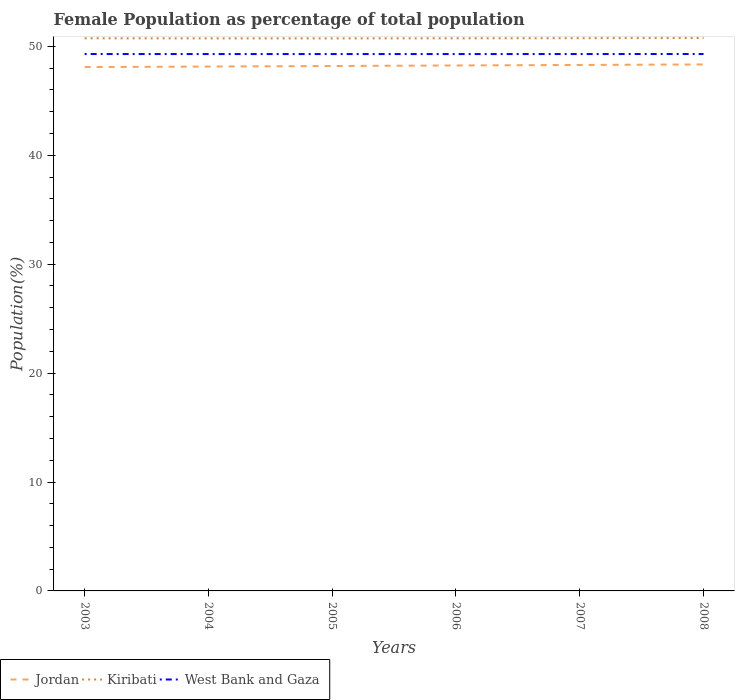How many different coloured lines are there?
Make the answer very short. 3. Does the line corresponding to West Bank and Gaza intersect with the line corresponding to Jordan?
Keep it short and to the point. No. Is the number of lines equal to the number of legend labels?
Keep it short and to the point. Yes. Across all years, what is the maximum female population in in West Bank and Gaza?
Keep it short and to the point. 49.29. In which year was the female population in in Kiribati maximum?
Give a very brief answer. 2005. What is the total female population in in Kiribati in the graph?
Provide a short and direct response. -0.01. What is the difference between the highest and the second highest female population in in Jordan?
Ensure brevity in your answer.  0.24. How many lines are there?
Offer a terse response. 3. Does the graph contain any zero values?
Make the answer very short. No. Does the graph contain grids?
Your answer should be compact. No. Where does the legend appear in the graph?
Your response must be concise. Bottom left. How are the legend labels stacked?
Provide a short and direct response. Horizontal. What is the title of the graph?
Provide a short and direct response. Female Population as percentage of total population. What is the label or title of the X-axis?
Keep it short and to the point. Years. What is the label or title of the Y-axis?
Make the answer very short. Population(%). What is the Population(%) in Jordan in 2003?
Your response must be concise. 48.09. What is the Population(%) of Kiribati in 2003?
Offer a terse response. 50.74. What is the Population(%) of West Bank and Gaza in 2003?
Your answer should be very brief. 49.29. What is the Population(%) of Jordan in 2004?
Provide a short and direct response. 48.14. What is the Population(%) in Kiribati in 2004?
Keep it short and to the point. 50.73. What is the Population(%) in West Bank and Gaza in 2004?
Offer a terse response. 49.29. What is the Population(%) in Jordan in 2005?
Provide a short and direct response. 48.19. What is the Population(%) of Kiribati in 2005?
Your answer should be compact. 50.73. What is the Population(%) of West Bank and Gaza in 2005?
Ensure brevity in your answer.  49.29. What is the Population(%) of Jordan in 2006?
Give a very brief answer. 48.24. What is the Population(%) in Kiribati in 2006?
Make the answer very short. 50.73. What is the Population(%) in West Bank and Gaza in 2006?
Provide a succinct answer. 49.29. What is the Population(%) in Jordan in 2007?
Ensure brevity in your answer.  48.29. What is the Population(%) of Kiribati in 2007?
Your answer should be compact. 50.75. What is the Population(%) of West Bank and Gaza in 2007?
Provide a short and direct response. 49.29. What is the Population(%) of Jordan in 2008?
Give a very brief answer. 48.34. What is the Population(%) in Kiribati in 2008?
Make the answer very short. 50.76. What is the Population(%) of West Bank and Gaza in 2008?
Keep it short and to the point. 49.29. Across all years, what is the maximum Population(%) of Jordan?
Your answer should be very brief. 48.34. Across all years, what is the maximum Population(%) of Kiribati?
Offer a very short reply. 50.76. Across all years, what is the maximum Population(%) of West Bank and Gaza?
Offer a terse response. 49.29. Across all years, what is the minimum Population(%) in Jordan?
Your answer should be very brief. 48.09. Across all years, what is the minimum Population(%) in Kiribati?
Your response must be concise. 50.73. Across all years, what is the minimum Population(%) of West Bank and Gaza?
Ensure brevity in your answer.  49.29. What is the total Population(%) in Jordan in the graph?
Make the answer very short. 289.3. What is the total Population(%) in Kiribati in the graph?
Make the answer very short. 304.44. What is the total Population(%) in West Bank and Gaza in the graph?
Keep it short and to the point. 295.74. What is the difference between the Population(%) in Jordan in 2003 and that in 2004?
Your answer should be very brief. -0.05. What is the difference between the Population(%) in Kiribati in 2003 and that in 2004?
Offer a terse response. 0.01. What is the difference between the Population(%) of West Bank and Gaza in 2003 and that in 2004?
Give a very brief answer. 0. What is the difference between the Population(%) of Jordan in 2003 and that in 2005?
Make the answer very short. -0.1. What is the difference between the Population(%) of Kiribati in 2003 and that in 2005?
Offer a terse response. 0.01. What is the difference between the Population(%) of West Bank and Gaza in 2003 and that in 2005?
Your answer should be compact. 0. What is the difference between the Population(%) of Jordan in 2003 and that in 2006?
Offer a very short reply. -0.15. What is the difference between the Population(%) in West Bank and Gaza in 2003 and that in 2006?
Keep it short and to the point. 0. What is the difference between the Population(%) in Jordan in 2003 and that in 2007?
Offer a terse response. -0.2. What is the difference between the Population(%) of Kiribati in 2003 and that in 2007?
Make the answer very short. -0.01. What is the difference between the Population(%) in Jordan in 2003 and that in 2008?
Your answer should be compact. -0.24. What is the difference between the Population(%) of Kiribati in 2003 and that in 2008?
Offer a very short reply. -0.03. What is the difference between the Population(%) in West Bank and Gaza in 2003 and that in 2008?
Your answer should be very brief. -0. What is the difference between the Population(%) in Jordan in 2004 and that in 2005?
Provide a succinct answer. -0.05. What is the difference between the Population(%) of Kiribati in 2004 and that in 2005?
Your answer should be compact. 0. What is the difference between the Population(%) of West Bank and Gaza in 2004 and that in 2005?
Keep it short and to the point. 0. What is the difference between the Population(%) in Jordan in 2004 and that in 2006?
Offer a very short reply. -0.1. What is the difference between the Population(%) in Kiribati in 2004 and that in 2006?
Your response must be concise. -0.01. What is the difference between the Population(%) in Jordan in 2004 and that in 2007?
Offer a terse response. -0.15. What is the difference between the Population(%) of Kiribati in 2004 and that in 2007?
Ensure brevity in your answer.  -0.02. What is the difference between the Population(%) in West Bank and Gaza in 2004 and that in 2007?
Ensure brevity in your answer.  -0. What is the difference between the Population(%) in Jordan in 2004 and that in 2008?
Provide a succinct answer. -0.2. What is the difference between the Population(%) in Kiribati in 2004 and that in 2008?
Keep it short and to the point. -0.03. What is the difference between the Population(%) of West Bank and Gaza in 2004 and that in 2008?
Give a very brief answer. -0. What is the difference between the Population(%) of Jordan in 2005 and that in 2006?
Your answer should be very brief. -0.05. What is the difference between the Population(%) of Kiribati in 2005 and that in 2006?
Provide a short and direct response. -0.01. What is the difference between the Population(%) of West Bank and Gaza in 2005 and that in 2006?
Keep it short and to the point. -0. What is the difference between the Population(%) of Jordan in 2005 and that in 2007?
Your response must be concise. -0.1. What is the difference between the Population(%) of Kiribati in 2005 and that in 2007?
Your answer should be very brief. -0.02. What is the difference between the Population(%) of West Bank and Gaza in 2005 and that in 2007?
Ensure brevity in your answer.  -0. What is the difference between the Population(%) in Jordan in 2005 and that in 2008?
Your answer should be compact. -0.14. What is the difference between the Population(%) in Kiribati in 2005 and that in 2008?
Offer a very short reply. -0.03. What is the difference between the Population(%) of West Bank and Gaza in 2005 and that in 2008?
Provide a short and direct response. -0. What is the difference between the Population(%) of Jordan in 2006 and that in 2007?
Provide a succinct answer. -0.05. What is the difference between the Population(%) of Kiribati in 2006 and that in 2007?
Provide a short and direct response. -0.01. What is the difference between the Population(%) of West Bank and Gaza in 2006 and that in 2007?
Your response must be concise. -0. What is the difference between the Population(%) of Jordan in 2006 and that in 2008?
Make the answer very short. -0.1. What is the difference between the Population(%) in Kiribati in 2006 and that in 2008?
Your response must be concise. -0.03. What is the difference between the Population(%) in West Bank and Gaza in 2006 and that in 2008?
Your answer should be very brief. -0. What is the difference between the Population(%) in Jordan in 2007 and that in 2008?
Make the answer very short. -0.05. What is the difference between the Population(%) in Kiribati in 2007 and that in 2008?
Make the answer very short. -0.01. What is the difference between the Population(%) in West Bank and Gaza in 2007 and that in 2008?
Make the answer very short. -0. What is the difference between the Population(%) of Jordan in 2003 and the Population(%) of Kiribati in 2004?
Make the answer very short. -2.63. What is the difference between the Population(%) in Jordan in 2003 and the Population(%) in West Bank and Gaza in 2004?
Provide a short and direct response. -1.2. What is the difference between the Population(%) of Kiribati in 2003 and the Population(%) of West Bank and Gaza in 2004?
Give a very brief answer. 1.45. What is the difference between the Population(%) of Jordan in 2003 and the Population(%) of Kiribati in 2005?
Your answer should be very brief. -2.63. What is the difference between the Population(%) in Jordan in 2003 and the Population(%) in West Bank and Gaza in 2005?
Your response must be concise. -1.2. What is the difference between the Population(%) of Kiribati in 2003 and the Population(%) of West Bank and Gaza in 2005?
Provide a short and direct response. 1.45. What is the difference between the Population(%) of Jordan in 2003 and the Population(%) of Kiribati in 2006?
Offer a terse response. -2.64. What is the difference between the Population(%) in Jordan in 2003 and the Population(%) in West Bank and Gaza in 2006?
Give a very brief answer. -1.2. What is the difference between the Population(%) of Kiribati in 2003 and the Population(%) of West Bank and Gaza in 2006?
Offer a very short reply. 1.45. What is the difference between the Population(%) in Jordan in 2003 and the Population(%) in Kiribati in 2007?
Ensure brevity in your answer.  -2.65. What is the difference between the Population(%) in Jordan in 2003 and the Population(%) in West Bank and Gaza in 2007?
Keep it short and to the point. -1.2. What is the difference between the Population(%) of Kiribati in 2003 and the Population(%) of West Bank and Gaza in 2007?
Keep it short and to the point. 1.45. What is the difference between the Population(%) in Jordan in 2003 and the Population(%) in Kiribati in 2008?
Give a very brief answer. -2.67. What is the difference between the Population(%) of Jordan in 2003 and the Population(%) of West Bank and Gaza in 2008?
Provide a short and direct response. -1.2. What is the difference between the Population(%) in Kiribati in 2003 and the Population(%) in West Bank and Gaza in 2008?
Offer a terse response. 1.44. What is the difference between the Population(%) in Jordan in 2004 and the Population(%) in Kiribati in 2005?
Give a very brief answer. -2.58. What is the difference between the Population(%) in Jordan in 2004 and the Population(%) in West Bank and Gaza in 2005?
Provide a short and direct response. -1.15. What is the difference between the Population(%) of Kiribati in 2004 and the Population(%) of West Bank and Gaza in 2005?
Your answer should be very brief. 1.44. What is the difference between the Population(%) of Jordan in 2004 and the Population(%) of Kiribati in 2006?
Provide a succinct answer. -2.59. What is the difference between the Population(%) in Jordan in 2004 and the Population(%) in West Bank and Gaza in 2006?
Keep it short and to the point. -1.15. What is the difference between the Population(%) in Kiribati in 2004 and the Population(%) in West Bank and Gaza in 2006?
Provide a succinct answer. 1.44. What is the difference between the Population(%) in Jordan in 2004 and the Population(%) in Kiribati in 2007?
Your response must be concise. -2.61. What is the difference between the Population(%) of Jordan in 2004 and the Population(%) of West Bank and Gaza in 2007?
Make the answer very short. -1.15. What is the difference between the Population(%) of Kiribati in 2004 and the Population(%) of West Bank and Gaza in 2007?
Offer a very short reply. 1.44. What is the difference between the Population(%) in Jordan in 2004 and the Population(%) in Kiribati in 2008?
Keep it short and to the point. -2.62. What is the difference between the Population(%) in Jordan in 2004 and the Population(%) in West Bank and Gaza in 2008?
Your answer should be compact. -1.15. What is the difference between the Population(%) of Kiribati in 2004 and the Population(%) of West Bank and Gaza in 2008?
Provide a succinct answer. 1.44. What is the difference between the Population(%) in Jordan in 2005 and the Population(%) in Kiribati in 2006?
Offer a very short reply. -2.54. What is the difference between the Population(%) of Jordan in 2005 and the Population(%) of West Bank and Gaza in 2006?
Ensure brevity in your answer.  -1.1. What is the difference between the Population(%) in Kiribati in 2005 and the Population(%) in West Bank and Gaza in 2006?
Offer a terse response. 1.44. What is the difference between the Population(%) in Jordan in 2005 and the Population(%) in Kiribati in 2007?
Offer a terse response. -2.56. What is the difference between the Population(%) of Jordan in 2005 and the Population(%) of West Bank and Gaza in 2007?
Provide a succinct answer. -1.1. What is the difference between the Population(%) of Kiribati in 2005 and the Population(%) of West Bank and Gaza in 2007?
Keep it short and to the point. 1.44. What is the difference between the Population(%) of Jordan in 2005 and the Population(%) of Kiribati in 2008?
Your response must be concise. -2.57. What is the difference between the Population(%) in Jordan in 2005 and the Population(%) in West Bank and Gaza in 2008?
Offer a very short reply. -1.1. What is the difference between the Population(%) of Kiribati in 2005 and the Population(%) of West Bank and Gaza in 2008?
Keep it short and to the point. 1.43. What is the difference between the Population(%) in Jordan in 2006 and the Population(%) in Kiribati in 2007?
Ensure brevity in your answer.  -2.51. What is the difference between the Population(%) of Jordan in 2006 and the Population(%) of West Bank and Gaza in 2007?
Your answer should be compact. -1.05. What is the difference between the Population(%) in Kiribati in 2006 and the Population(%) in West Bank and Gaza in 2007?
Offer a very short reply. 1.44. What is the difference between the Population(%) in Jordan in 2006 and the Population(%) in Kiribati in 2008?
Keep it short and to the point. -2.52. What is the difference between the Population(%) in Jordan in 2006 and the Population(%) in West Bank and Gaza in 2008?
Your answer should be very brief. -1.05. What is the difference between the Population(%) in Kiribati in 2006 and the Population(%) in West Bank and Gaza in 2008?
Offer a very short reply. 1.44. What is the difference between the Population(%) of Jordan in 2007 and the Population(%) of Kiribati in 2008?
Make the answer very short. -2.47. What is the difference between the Population(%) in Jordan in 2007 and the Population(%) in West Bank and Gaza in 2008?
Give a very brief answer. -1. What is the difference between the Population(%) of Kiribati in 2007 and the Population(%) of West Bank and Gaza in 2008?
Offer a very short reply. 1.45. What is the average Population(%) of Jordan per year?
Your response must be concise. 48.22. What is the average Population(%) in Kiribati per year?
Your response must be concise. 50.74. What is the average Population(%) of West Bank and Gaza per year?
Ensure brevity in your answer.  49.29. In the year 2003, what is the difference between the Population(%) of Jordan and Population(%) of Kiribati?
Your answer should be compact. -2.64. In the year 2003, what is the difference between the Population(%) in Jordan and Population(%) in West Bank and Gaza?
Make the answer very short. -1.2. In the year 2003, what is the difference between the Population(%) of Kiribati and Population(%) of West Bank and Gaza?
Provide a short and direct response. 1.44. In the year 2004, what is the difference between the Population(%) in Jordan and Population(%) in Kiribati?
Your answer should be very brief. -2.59. In the year 2004, what is the difference between the Population(%) of Jordan and Population(%) of West Bank and Gaza?
Your response must be concise. -1.15. In the year 2004, what is the difference between the Population(%) of Kiribati and Population(%) of West Bank and Gaza?
Provide a short and direct response. 1.44. In the year 2005, what is the difference between the Population(%) of Jordan and Population(%) of Kiribati?
Your response must be concise. -2.53. In the year 2005, what is the difference between the Population(%) of Jordan and Population(%) of West Bank and Gaza?
Provide a succinct answer. -1.1. In the year 2005, what is the difference between the Population(%) of Kiribati and Population(%) of West Bank and Gaza?
Give a very brief answer. 1.44. In the year 2006, what is the difference between the Population(%) in Jordan and Population(%) in Kiribati?
Your answer should be very brief. -2.49. In the year 2006, what is the difference between the Population(%) of Jordan and Population(%) of West Bank and Gaza?
Offer a terse response. -1.05. In the year 2006, what is the difference between the Population(%) of Kiribati and Population(%) of West Bank and Gaza?
Offer a terse response. 1.45. In the year 2007, what is the difference between the Population(%) in Jordan and Population(%) in Kiribati?
Your response must be concise. -2.46. In the year 2007, what is the difference between the Population(%) in Jordan and Population(%) in West Bank and Gaza?
Ensure brevity in your answer.  -1. In the year 2007, what is the difference between the Population(%) in Kiribati and Population(%) in West Bank and Gaza?
Make the answer very short. 1.46. In the year 2008, what is the difference between the Population(%) of Jordan and Population(%) of Kiribati?
Keep it short and to the point. -2.42. In the year 2008, what is the difference between the Population(%) in Jordan and Population(%) in West Bank and Gaza?
Your answer should be very brief. -0.96. In the year 2008, what is the difference between the Population(%) of Kiribati and Population(%) of West Bank and Gaza?
Your response must be concise. 1.47. What is the ratio of the Population(%) in Jordan in 2003 to that in 2004?
Offer a terse response. 1. What is the ratio of the Population(%) of Kiribati in 2003 to that in 2004?
Make the answer very short. 1. What is the ratio of the Population(%) of Kiribati in 2003 to that in 2006?
Keep it short and to the point. 1. What is the ratio of the Population(%) in West Bank and Gaza in 2003 to that in 2006?
Your answer should be compact. 1. What is the ratio of the Population(%) of West Bank and Gaza in 2003 to that in 2007?
Give a very brief answer. 1. What is the ratio of the Population(%) in Jordan in 2004 to that in 2005?
Make the answer very short. 1. What is the ratio of the Population(%) in West Bank and Gaza in 2004 to that in 2005?
Ensure brevity in your answer.  1. What is the ratio of the Population(%) of Jordan in 2004 to that in 2007?
Provide a succinct answer. 1. What is the ratio of the Population(%) in Jordan in 2004 to that in 2008?
Keep it short and to the point. 1. What is the ratio of the Population(%) in Jordan in 2005 to that in 2006?
Your answer should be very brief. 1. What is the ratio of the Population(%) of Kiribati in 2005 to that in 2006?
Your answer should be compact. 1. What is the ratio of the Population(%) of Jordan in 2005 to that in 2007?
Provide a succinct answer. 1. What is the ratio of the Population(%) of Kiribati in 2005 to that in 2007?
Your response must be concise. 1. What is the ratio of the Population(%) in West Bank and Gaza in 2005 to that in 2007?
Make the answer very short. 1. What is the ratio of the Population(%) in Jordan in 2005 to that in 2008?
Your response must be concise. 1. What is the ratio of the Population(%) in Kiribati in 2006 to that in 2007?
Provide a short and direct response. 1. What is the ratio of the Population(%) in West Bank and Gaza in 2006 to that in 2007?
Give a very brief answer. 1. What is the ratio of the Population(%) in Jordan in 2006 to that in 2008?
Your answer should be very brief. 1. What is the ratio of the Population(%) in Jordan in 2007 to that in 2008?
Ensure brevity in your answer.  1. What is the ratio of the Population(%) in Kiribati in 2007 to that in 2008?
Offer a very short reply. 1. What is the difference between the highest and the second highest Population(%) of Jordan?
Provide a succinct answer. 0.05. What is the difference between the highest and the second highest Population(%) of Kiribati?
Ensure brevity in your answer.  0.01. What is the difference between the highest and the second highest Population(%) in West Bank and Gaza?
Offer a very short reply. 0. What is the difference between the highest and the lowest Population(%) of Jordan?
Make the answer very short. 0.24. What is the difference between the highest and the lowest Population(%) in Kiribati?
Your answer should be very brief. 0.03. What is the difference between the highest and the lowest Population(%) in West Bank and Gaza?
Offer a very short reply. 0. 